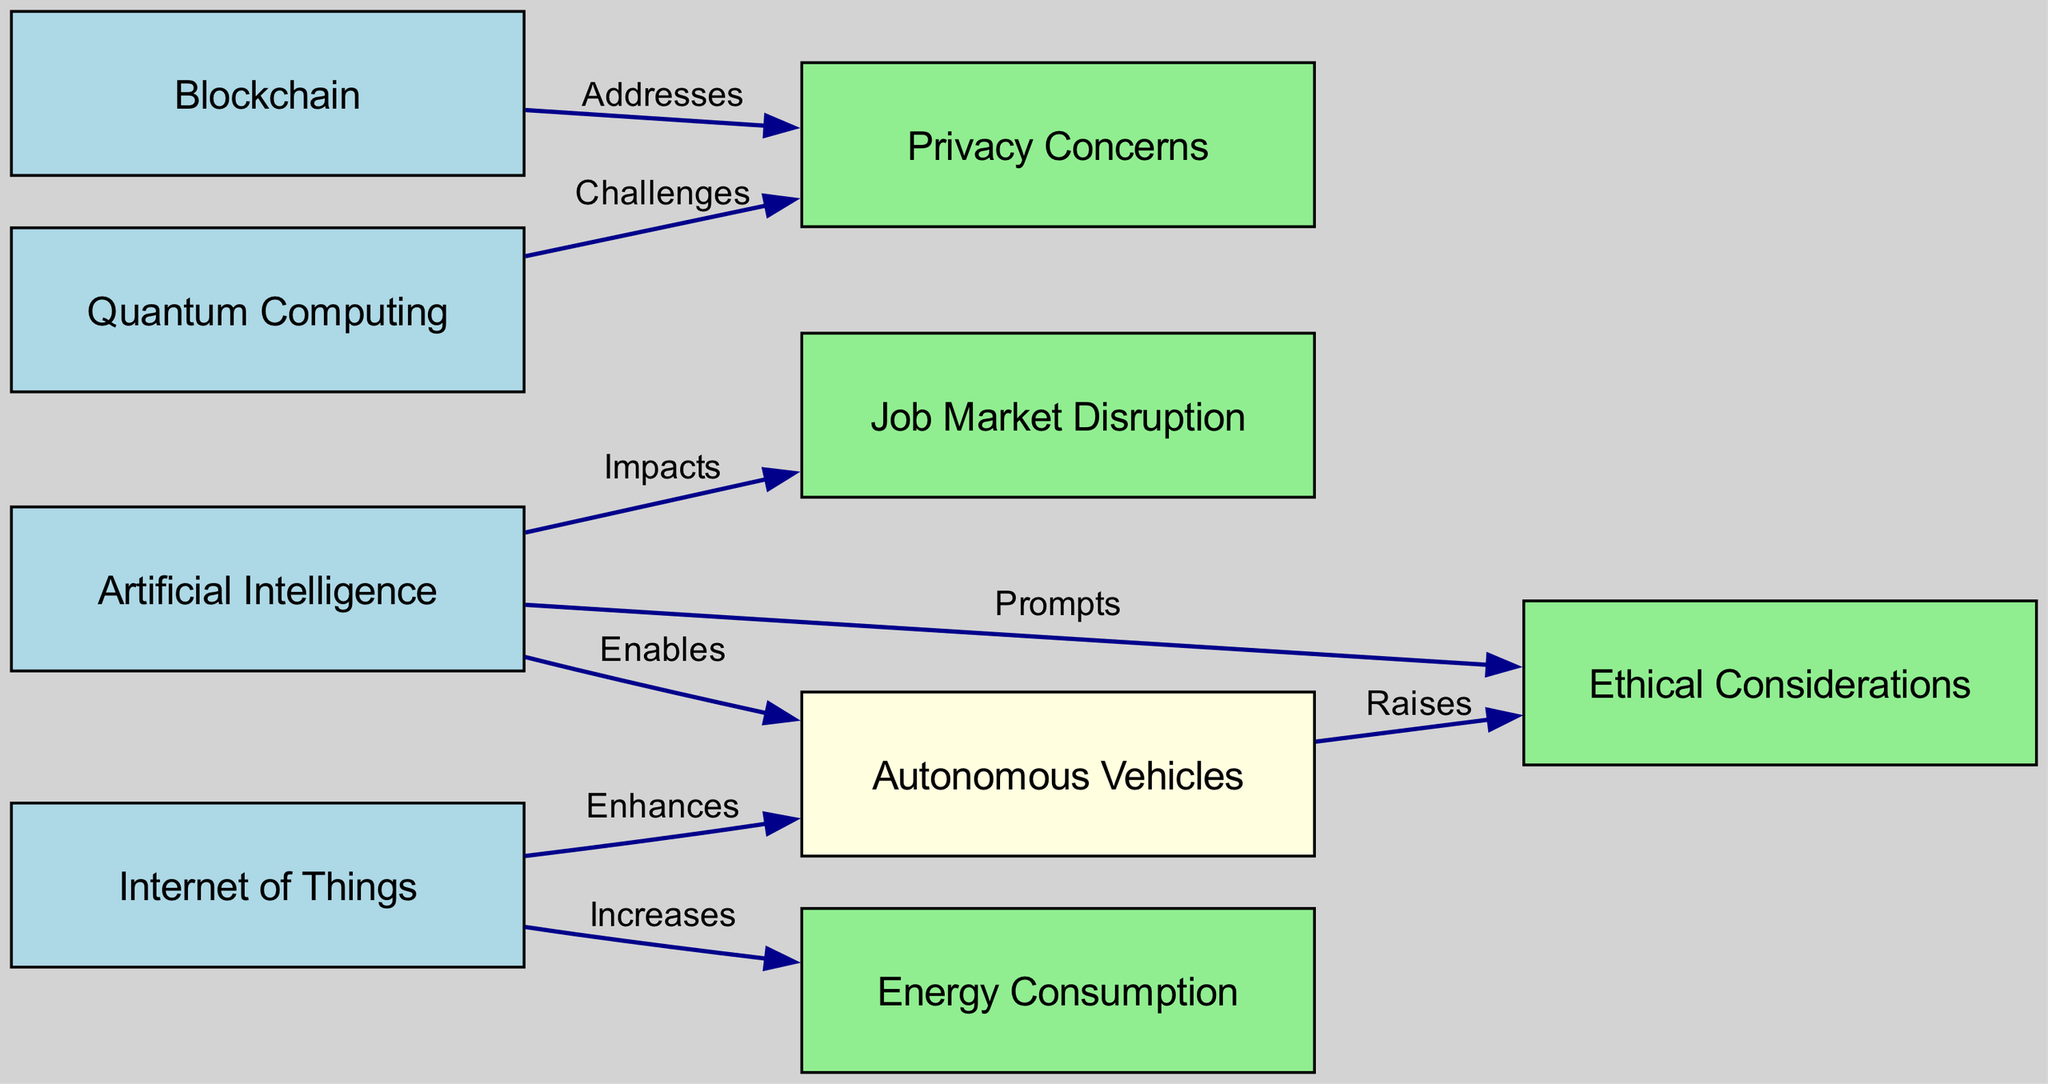What is the total number of nodes in the diagram? The diagram contains various nodes representing technologies and societal impacts. By counting each distinct node listed in the "nodes" section of the data (1 to 9), we find there are a total of 9 nodes.
Answer: 9 Which technology is listed as raising ethical considerations? The relationships between nodes indicate that Autonomous Vehicles (node 5) raises Ethical Considerations (node 9). This can be deduced from the directed edge labeled "Raises" connecting these two nodes.
Answer: Autonomous Vehicles How many edges are connecting technologies to societal impacts? By analyzing the edges, we note that there are a total of 6 edges that connect technologies to the nodes representing societal impacts. Counting these specific edges that lead to nodes 6 (Privacy Concerns), 7 (Job Market Disruption), and 9 (Ethical Considerations), gives us the count of connections.
Answer: 6 What relationship does Blockchain have with Privacy Concerns? The diagram states that Blockchain (node 2) addresses Privacy Concerns (node 6). This is evident from the directed edge labeled "Addresses" connecting these two nodes.
Answer: Addresses Which technology enhances Autonomous Vehicles? By looking at the connections stemming from the Internet of Things (node 3), we see an edge marked "Enhances" that connects to Autonomous Vehicles (node 5). Thus, the relationship indicates that the Internet of Things enhances Autonomous Vehicles.
Answer: Internet of Things Which technology enables Autonomous Vehicles? According to the diagram, Artificial Intelligence (node 1) is labeled as the technology that enables Autonomous Vehicles (node 5). This relationship is clearly depicted by the directed edge labeled "Enables."
Answer: Artificial Intelligence 